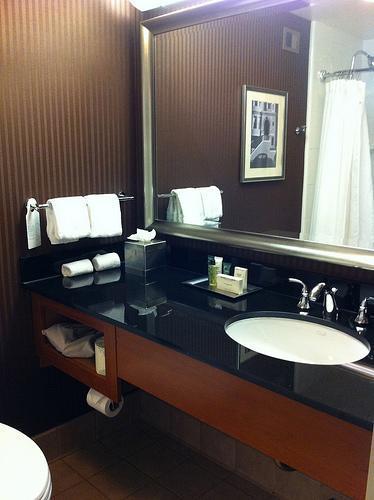How many sinks are in the bathroom?
Give a very brief answer. 1. How many towels are hanging on the bar?
Give a very brief answer. 2. 